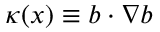<formula> <loc_0><loc_0><loc_500><loc_500>\kappa ( x ) \equiv b \cdot \nabla b</formula> 